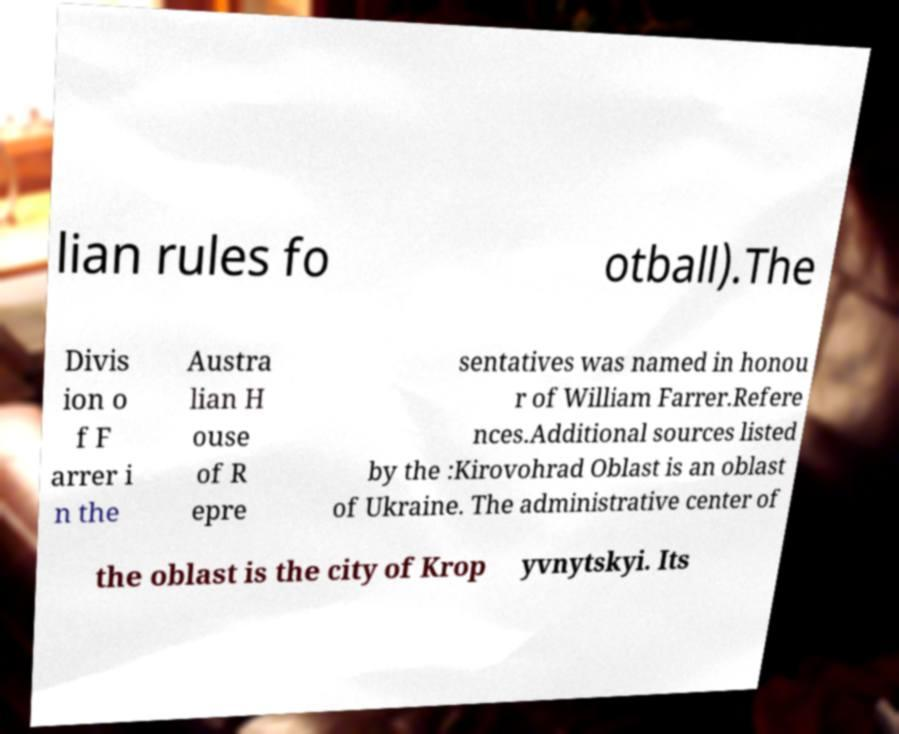Can you accurately transcribe the text from the provided image for me? lian rules fo otball).The Divis ion o f F arrer i n the Austra lian H ouse of R epre sentatives was named in honou r of William Farrer.Refere nces.Additional sources listed by the :Kirovohrad Oblast is an oblast of Ukraine. The administrative center of the oblast is the city of Krop yvnytskyi. Its 